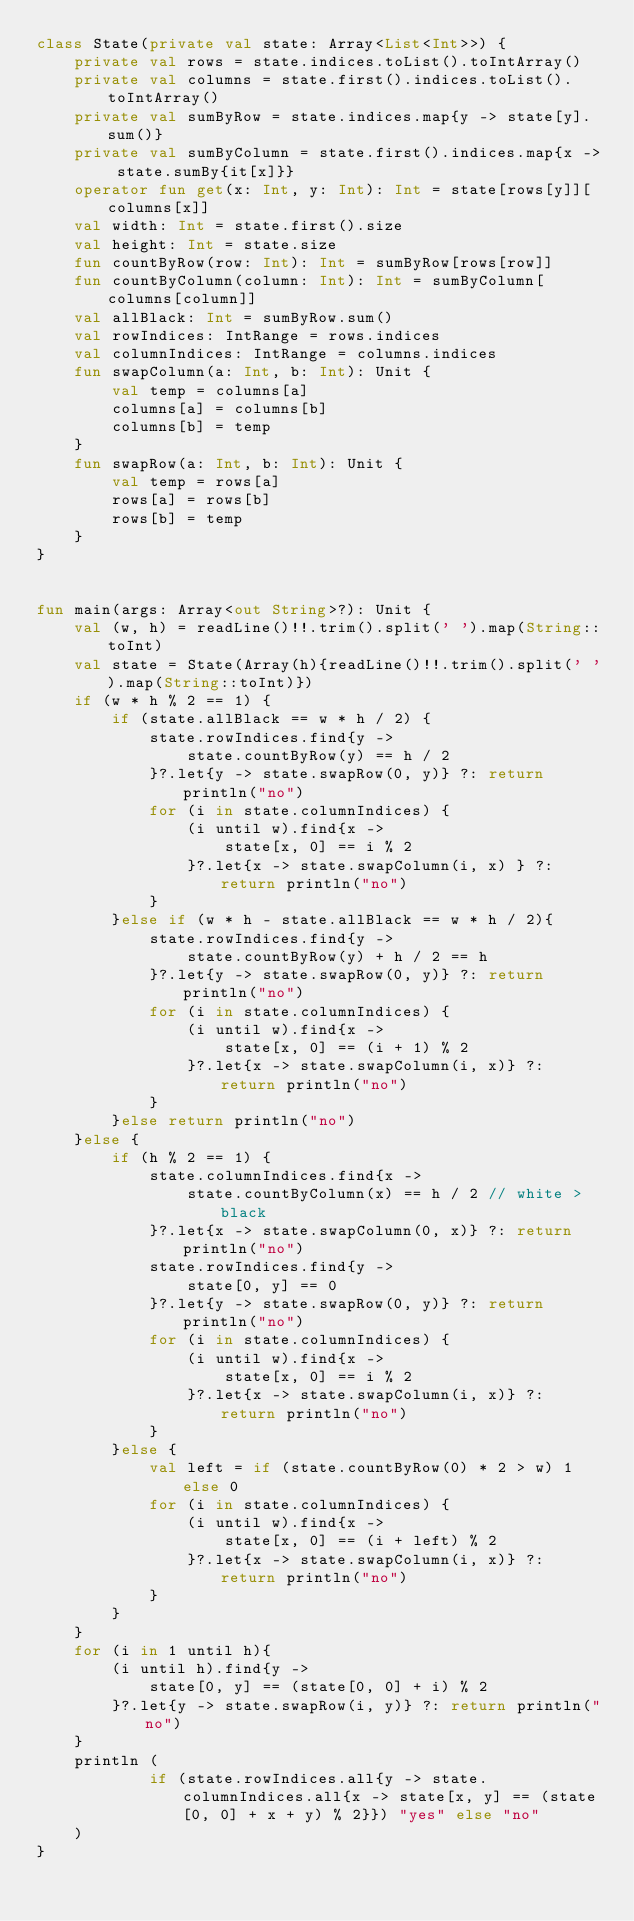Convert code to text. <code><loc_0><loc_0><loc_500><loc_500><_Kotlin_>class State(private val state: Array<List<Int>>) {
    private val rows = state.indices.toList().toIntArray()
    private val columns = state.first().indices.toList().toIntArray()
    private val sumByRow = state.indices.map{y -> state[y].sum()}
    private val sumByColumn = state.first().indices.map{x -> state.sumBy{it[x]}}
    operator fun get(x: Int, y: Int): Int = state[rows[y]][columns[x]]
    val width: Int = state.first().size
    val height: Int = state.size
    fun countByRow(row: Int): Int = sumByRow[rows[row]]
    fun countByColumn(column: Int): Int = sumByColumn[columns[column]]
    val allBlack: Int = sumByRow.sum()
    val rowIndices: IntRange = rows.indices
    val columnIndices: IntRange = columns.indices
    fun swapColumn(a: Int, b: Int): Unit {
        val temp = columns[a]
        columns[a] = columns[b]
        columns[b] = temp
    }
    fun swapRow(a: Int, b: Int): Unit {
        val temp = rows[a]
        rows[a] = rows[b]
        rows[b] = temp
    }
}


fun main(args: Array<out String>?): Unit {
    val (w, h) = readLine()!!.trim().split(' ').map(String::toInt)
    val state = State(Array(h){readLine()!!.trim().split(' ').map(String::toInt)})
    if (w * h % 2 == 1) {
        if (state.allBlack == w * h / 2) {
            state.rowIndices.find{y ->
                state.countByRow(y) == h / 2
            }?.let{y -> state.swapRow(0, y)} ?: return println("no")
            for (i in state.columnIndices) {
                (i until w).find{x ->
                    state[x, 0] == i % 2
                }?.let{x -> state.swapColumn(i, x) } ?: return println("no")
            }
        }else if (w * h - state.allBlack == w * h / 2){
            state.rowIndices.find{y ->
                state.countByRow(y) + h / 2 == h
            }?.let{y -> state.swapRow(0, y)} ?: return println("no")
            for (i in state.columnIndices) {
                (i until w).find{x ->
                    state[x, 0] == (i + 1) % 2
                }?.let{x -> state.swapColumn(i, x)} ?: return println("no")
            }
        }else return println("no")
    }else {
        if (h % 2 == 1) {
            state.columnIndices.find{x ->
                state.countByColumn(x) == h / 2 // white > black
            }?.let{x -> state.swapColumn(0, x)} ?: return println("no")
            state.rowIndices.find{y ->
                state[0, y] == 0
            }?.let{y -> state.swapRow(0, y)} ?: return println("no")
            for (i in state.columnIndices) {
                (i until w).find{x ->
                    state[x, 0] == i % 2
                }?.let{x -> state.swapColumn(i, x)} ?: return println("no")
            }
        }else {
            val left = if (state.countByRow(0) * 2 > w) 1 else 0
            for (i in state.columnIndices) {
                (i until w).find{x ->
                    state[x, 0] == (i + left) % 2
                }?.let{x -> state.swapColumn(i, x)} ?: return println("no")
            }
        }
    }
    for (i in 1 until h){
        (i until h).find{y ->
            state[0, y] == (state[0, 0] + i) % 2
        }?.let{y -> state.swapRow(i, y)} ?: return println("no")
    }
    println (
            if (state.rowIndices.all{y -> state.columnIndices.all{x -> state[x, y] == (state[0, 0] + x + y) % 2}}) "yes" else "no"
    )
}
</code> 